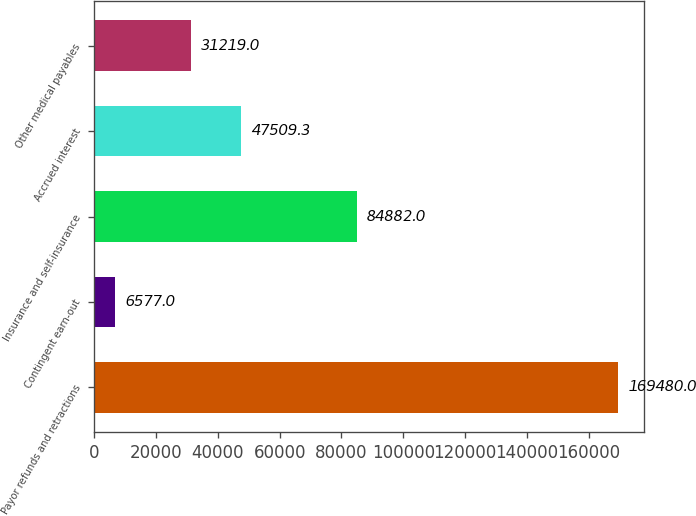Convert chart. <chart><loc_0><loc_0><loc_500><loc_500><bar_chart><fcel>Payor refunds and retractions<fcel>Contingent earn-out<fcel>Insurance and self-insurance<fcel>Accrued interest<fcel>Other medical payables<nl><fcel>169480<fcel>6577<fcel>84882<fcel>47509.3<fcel>31219<nl></chart> 